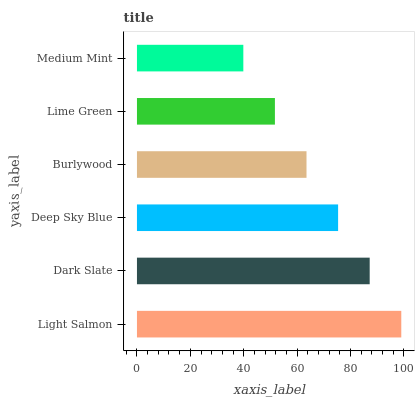Is Medium Mint the minimum?
Answer yes or no. Yes. Is Light Salmon the maximum?
Answer yes or no. Yes. Is Dark Slate the minimum?
Answer yes or no. No. Is Dark Slate the maximum?
Answer yes or no. No. Is Light Salmon greater than Dark Slate?
Answer yes or no. Yes. Is Dark Slate less than Light Salmon?
Answer yes or no. Yes. Is Dark Slate greater than Light Salmon?
Answer yes or no. No. Is Light Salmon less than Dark Slate?
Answer yes or no. No. Is Deep Sky Blue the high median?
Answer yes or no. Yes. Is Burlywood the low median?
Answer yes or no. Yes. Is Dark Slate the high median?
Answer yes or no. No. Is Medium Mint the low median?
Answer yes or no. No. 